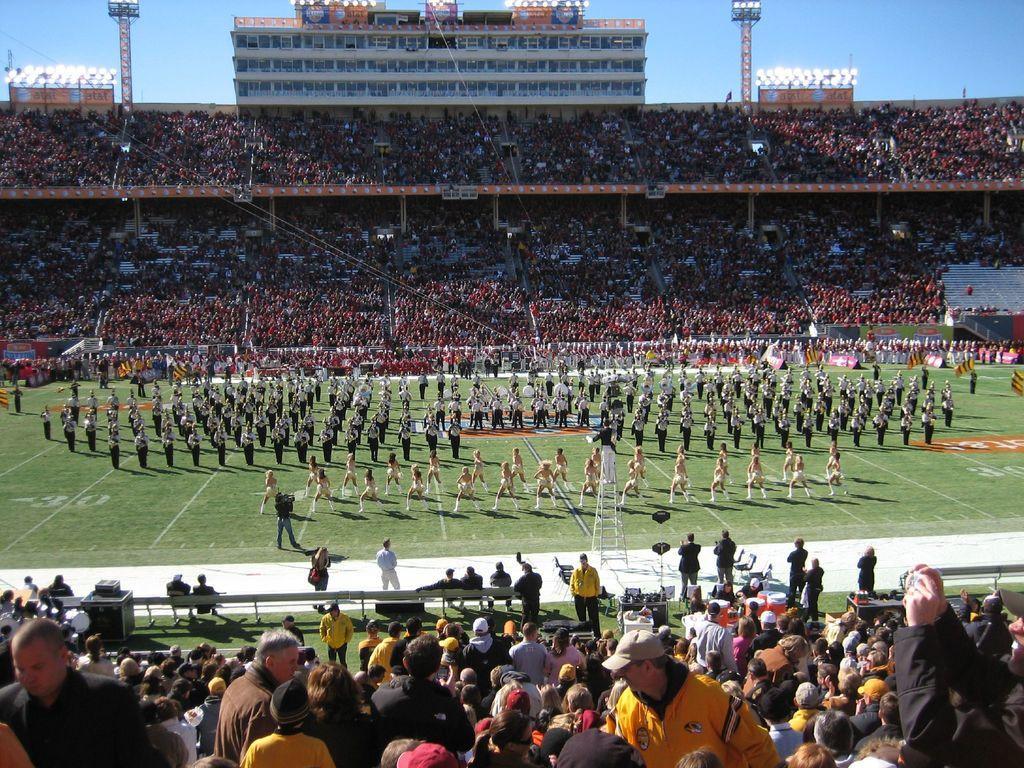How would you summarize this image in a sentence or two? In this image we can see a stadium. In that there are a few people standing on the ground and a few people sitting on the chairs. And there is a building with boards and lights. There are boxes and the sky. And we can see a person standing on the ladder. 